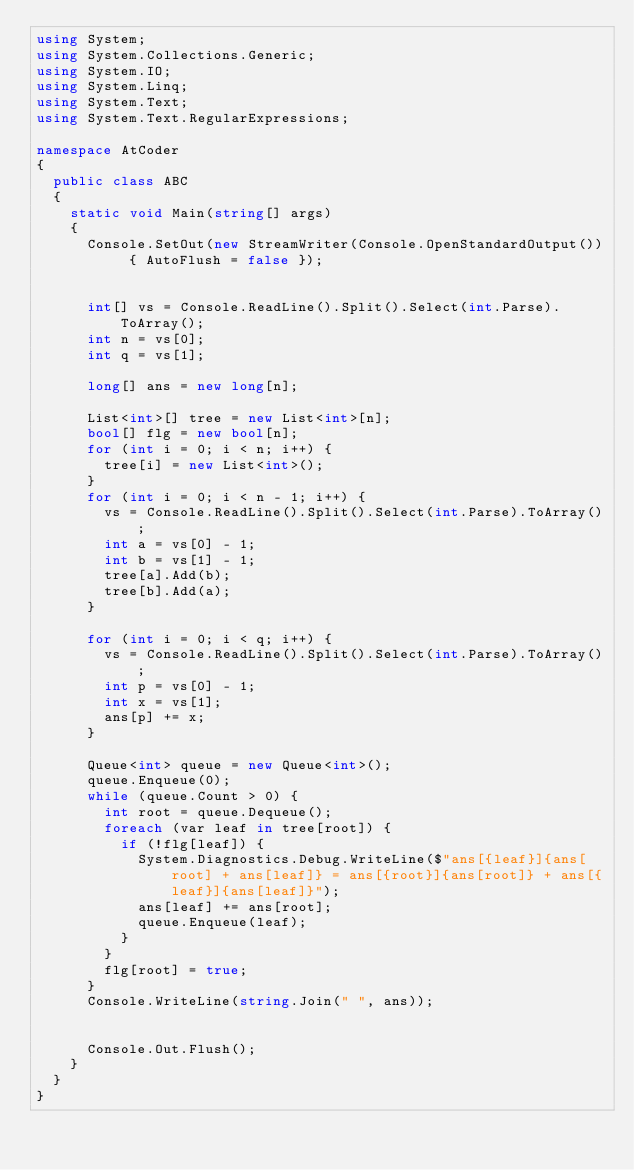Convert code to text. <code><loc_0><loc_0><loc_500><loc_500><_C#_>using System;
using System.Collections.Generic;
using System.IO;
using System.Linq;
using System.Text;
using System.Text.RegularExpressions;

namespace AtCoder
{
	public class ABC
	{
		static void Main(string[] args)
		{
			Console.SetOut(new StreamWriter(Console.OpenStandardOutput()) { AutoFlush = false });


			int[] vs = Console.ReadLine().Split().Select(int.Parse).ToArray();
			int n = vs[0];
			int q = vs[1];

			long[] ans = new long[n];

			List<int>[] tree = new List<int>[n];
			bool[] flg = new bool[n];
			for (int i = 0; i < n; i++) {
				tree[i] = new List<int>();
			}
			for (int i = 0; i < n - 1; i++) {
				vs = Console.ReadLine().Split().Select(int.Parse).ToArray();
				int a = vs[0] - 1;
				int b = vs[1] - 1;
				tree[a].Add(b);
				tree[b].Add(a);
			}

			for (int i = 0; i < q; i++) {
				vs = Console.ReadLine().Split().Select(int.Parse).ToArray();
				int p = vs[0] - 1;
				int x = vs[1];
				ans[p] += x;
			}

			Queue<int> queue = new Queue<int>();
			queue.Enqueue(0);
			while (queue.Count > 0) {
				int root = queue.Dequeue();
				foreach (var leaf in tree[root]) {
					if (!flg[leaf]) {
						System.Diagnostics.Debug.WriteLine($"ans[{leaf}]{ans[root] + ans[leaf]} = ans[{root}]{ans[root]} + ans[{leaf}]{ans[leaf]}");
						ans[leaf] += ans[root];
						queue.Enqueue(leaf);
					}
				}
				flg[root] = true;
			}
			Console.WriteLine(string.Join(" ", ans));


			Console.Out.Flush();
		}
	}
}
</code> 